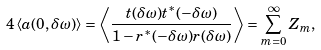<formula> <loc_0><loc_0><loc_500><loc_500>4 \left \langle a ( 0 , \delta \omega ) \right \rangle = \left \langle \frac { t ( \delta \omega ) t ^ { * } ( - \delta \omega ) } { 1 - r ^ { * } ( - \delta \omega ) r ( \delta \omega ) } \right \rangle = \sum _ { m = 0 } ^ { \infty } Z _ { m } ,</formula> 